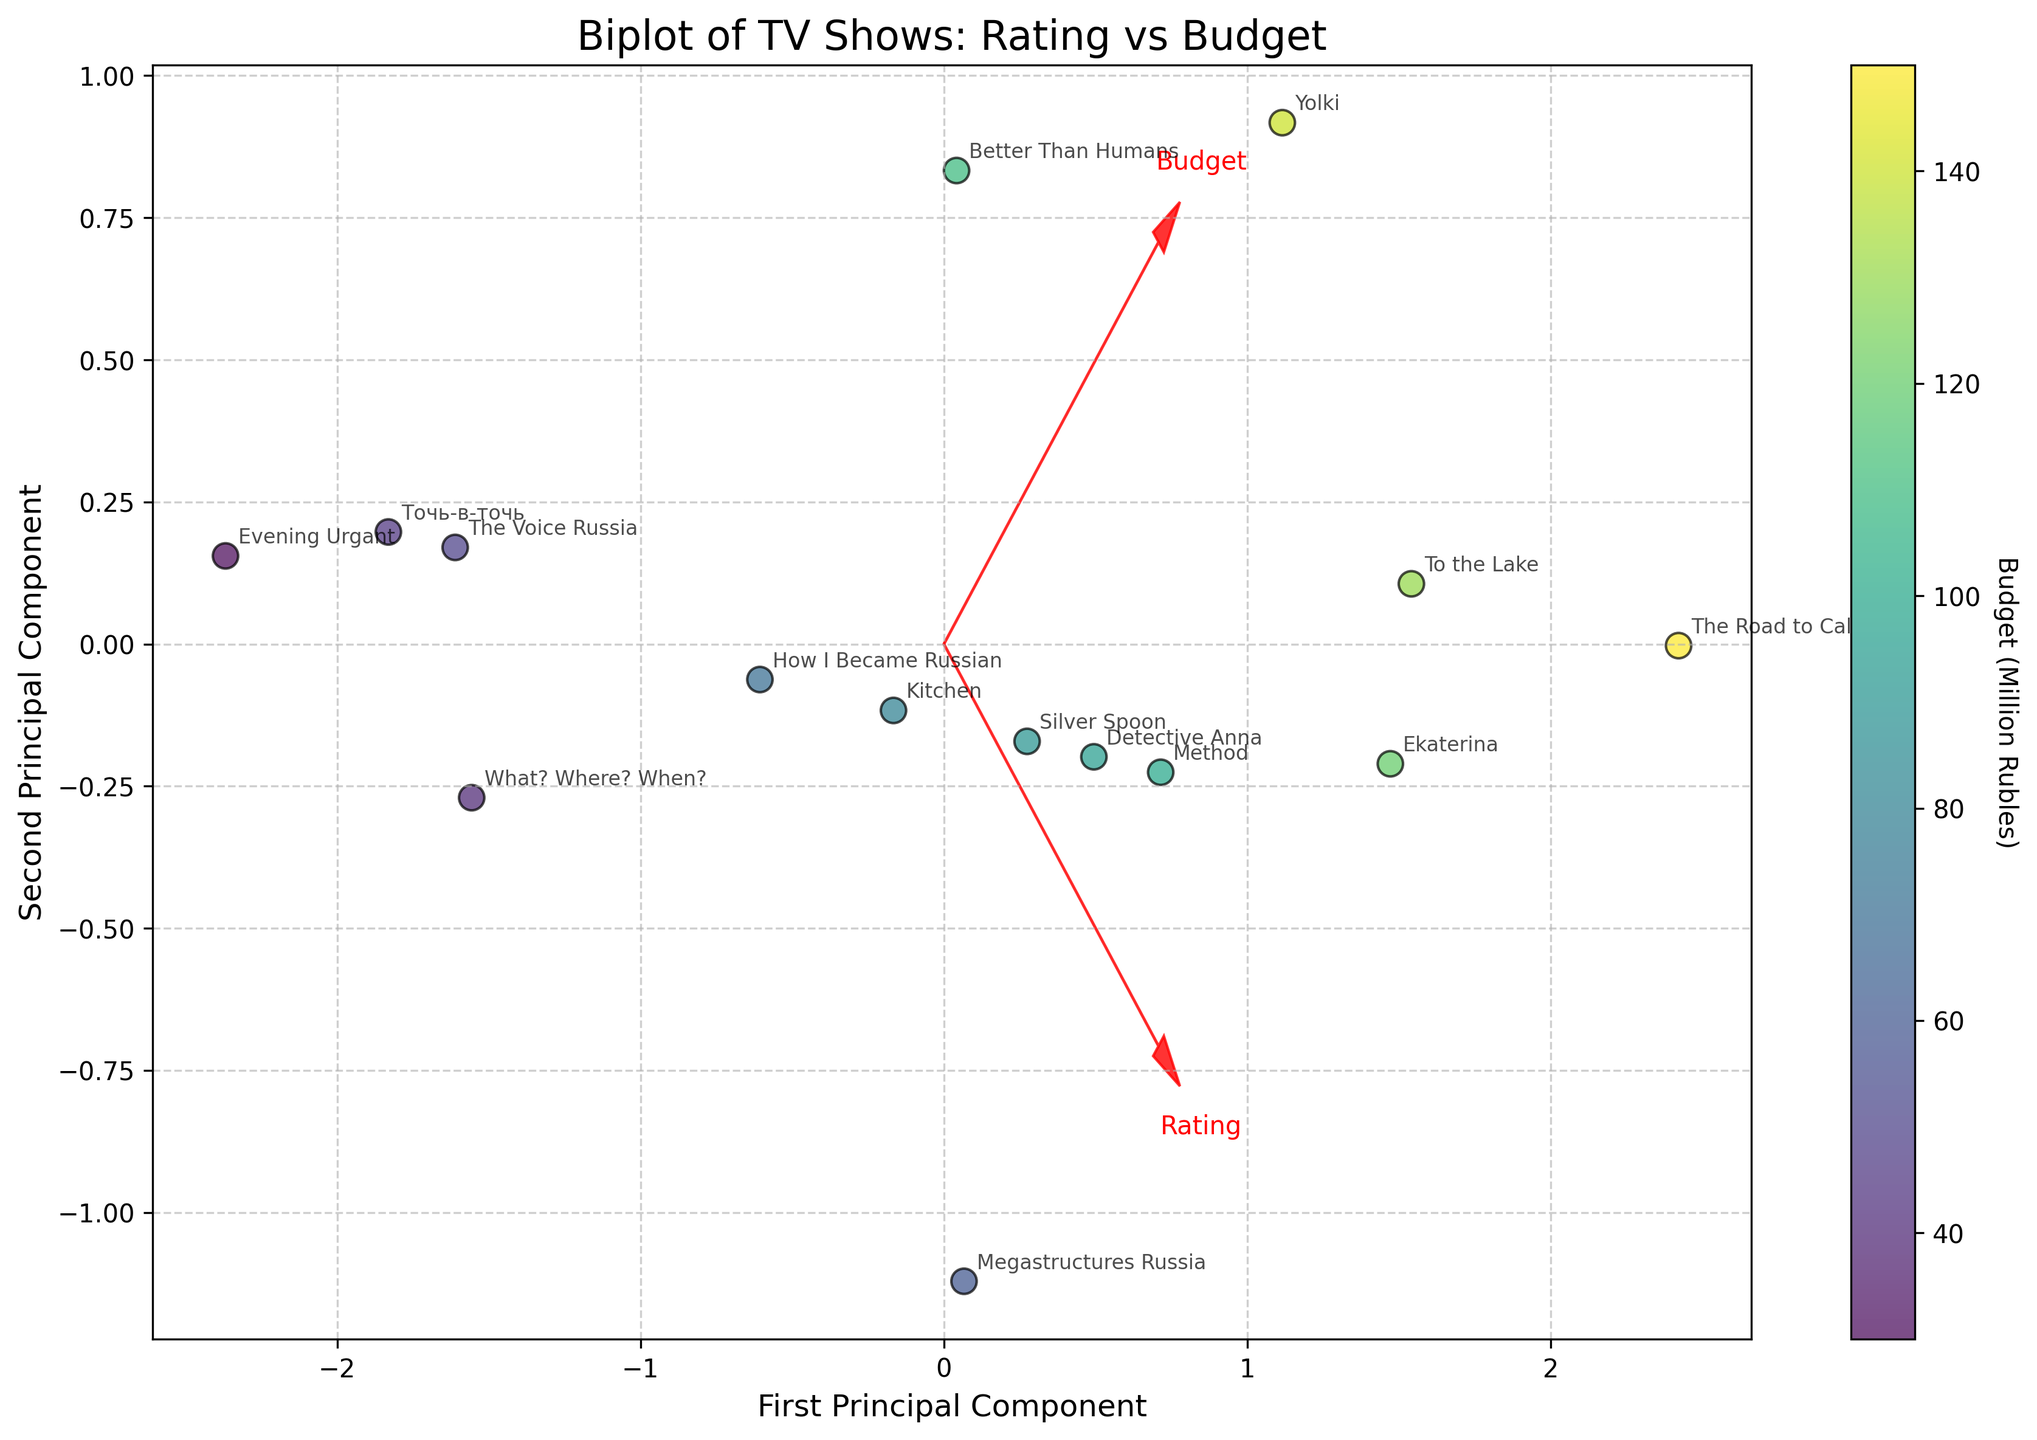What is the title of the figure? The title is usually located at the top of the figure. In this case, look at the center of the plot to find it.
Answer: Biplot of TV Shows: Rating vs Budget How many TV shows are plotted in the figure? Count the number of data points (scatter points) in the figure.
Answer: 15 Which TV show is associated with the highest budget? Find the point with the highest Budget (color bar/cmap) and look at the annotation for the corresponding TV show name.
Answer: The Road to Calvary Which genre has a TV show with the lowest rating? Look at the scatter points towards the lower end of the 'Rating' arrow and find the genre associated with the annotated TV show name there.
Answer: Variety What is the relationship between the first principal component and 'Rating'? Look for the direction of the 'Rating' arrow relative to the first principal component (X-axis). If the arrow points in the same direction or the opposite, it suggests correlation.
Answer: Correlated Which two genres have TV shows with similar ratings but different budgets? Look for two points near each other along the 'Rating' arrow but differing in color intensity, then check their annotations.
Answer: Drama (Ekaterina) and Historical (The Road to Calvary) Which TV show lies closest to the origin in the biplot? Identify the data point nearest to (0, 0) and check its annotation.
Answer: What? Where? When? What does the color of the scatter points represent? The color usually indicates a variable, look at the color bar to determine which variable it represents.
Answer: Budget (Million Rubles) Which TV show has a rating higher than 8.0 but a relatively moderate budget? Focus on points higher along the 'Rating' arrow above the 8.0 marker, and medium color intensity in the color bar.
Answer: Documentary (Megastructures Russia) How do 'Rating' and 'Budget' contribute to the second principal component? Look at the projection of 'Rating' and 'Budget' arrows on the second principal component (Y-axis) to judge their contribution.
Answer: Both have projections near zero 